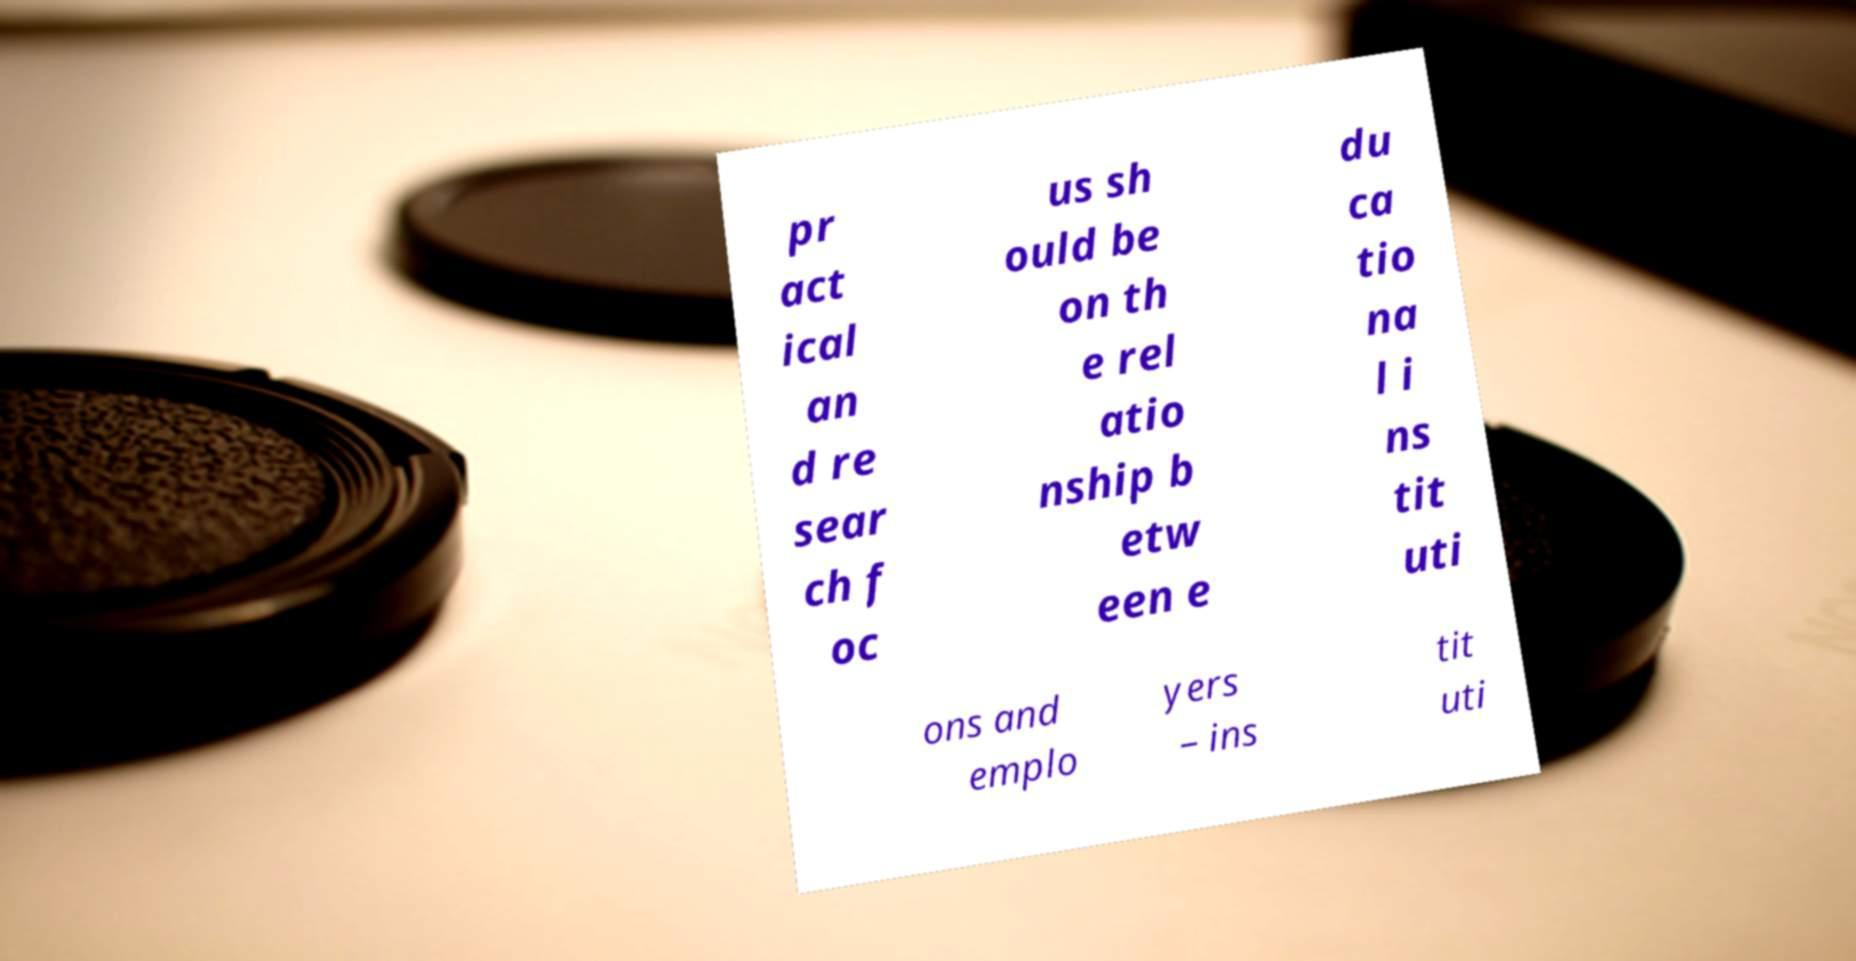For documentation purposes, I need the text within this image transcribed. Could you provide that? pr act ical an d re sear ch f oc us sh ould be on th e rel atio nship b etw een e du ca tio na l i ns tit uti ons and emplo yers – ins tit uti 